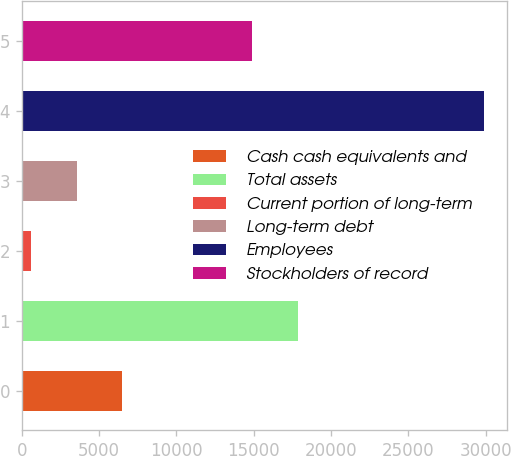Convert chart to OTSL. <chart><loc_0><loc_0><loc_500><loc_500><bar_chart><fcel>Cash cash equivalents and<fcel>Total assets<fcel>Current portion of long-term<fcel>Long-term debt<fcel>Employees<fcel>Stockholders of record<nl><fcel>6477.8<fcel>17833.4<fcel>631<fcel>3554.4<fcel>29865<fcel>14910<nl></chart> 